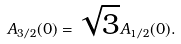<formula> <loc_0><loc_0><loc_500><loc_500>A _ { 3 / 2 } ( 0 ) = \sqrt { 3 } A _ { 1 / 2 } ( 0 ) .</formula> 